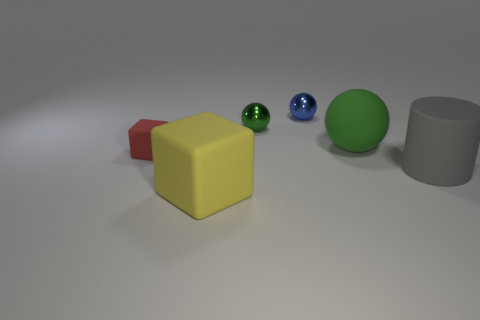What materials do the different objects in the image seem to be made of based on their appearance? The materials of the objects in the image can be inferred by their textures and reflections. The cylinder and the two spheres appear to have reflective surfaces, suggesting they could be made of metal or plastic. The yellow cube seems to be rubber due to its matte texture, while the red block looks matte and could possibly be made of wood or matte plastic. 